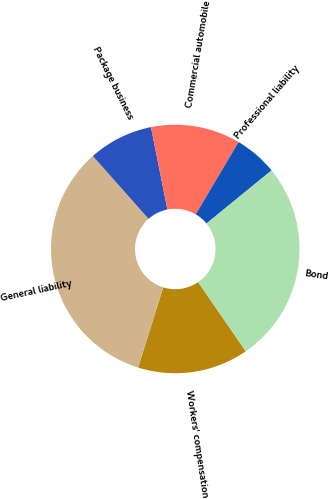Convert chart to OTSL. <chart><loc_0><loc_0><loc_500><loc_500><pie_chart><fcel>Workers' compensation<fcel>General liability<fcel>Package business<fcel>Commercial automobile<fcel>Professional liability<fcel>Bond<nl><fcel>14.44%<fcel>33.62%<fcel>8.41%<fcel>11.64%<fcel>5.6%<fcel>26.29%<nl></chart> 